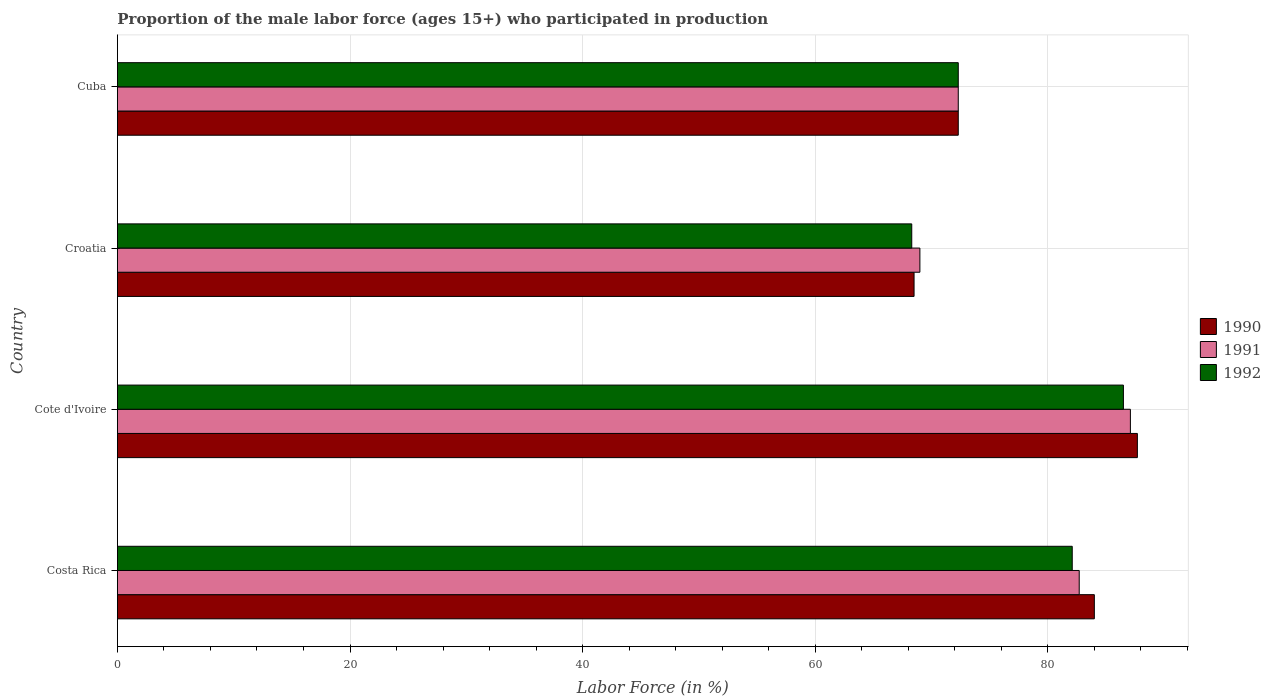How many groups of bars are there?
Provide a short and direct response. 4. Are the number of bars per tick equal to the number of legend labels?
Provide a succinct answer. Yes. Are the number of bars on each tick of the Y-axis equal?
Your answer should be very brief. Yes. How many bars are there on the 4th tick from the top?
Offer a terse response. 3. What is the label of the 2nd group of bars from the top?
Offer a very short reply. Croatia. What is the proportion of the male labor force who participated in production in 1991 in Croatia?
Provide a short and direct response. 69. Across all countries, what is the maximum proportion of the male labor force who participated in production in 1990?
Give a very brief answer. 87.7. Across all countries, what is the minimum proportion of the male labor force who participated in production in 1990?
Keep it short and to the point. 68.5. In which country was the proportion of the male labor force who participated in production in 1992 maximum?
Ensure brevity in your answer.  Cote d'Ivoire. In which country was the proportion of the male labor force who participated in production in 1990 minimum?
Make the answer very short. Croatia. What is the total proportion of the male labor force who participated in production in 1991 in the graph?
Your answer should be very brief. 311.1. What is the difference between the proportion of the male labor force who participated in production in 1992 in Costa Rica and that in Cote d'Ivoire?
Offer a terse response. -4.4. What is the difference between the proportion of the male labor force who participated in production in 1991 in Croatia and the proportion of the male labor force who participated in production in 1992 in Cote d'Ivoire?
Provide a short and direct response. -17.5. What is the average proportion of the male labor force who participated in production in 1992 per country?
Keep it short and to the point. 77.3. What is the difference between the proportion of the male labor force who participated in production in 1992 and proportion of the male labor force who participated in production in 1991 in Costa Rica?
Your response must be concise. -0.6. What is the ratio of the proportion of the male labor force who participated in production in 1990 in Costa Rica to that in Cuba?
Give a very brief answer. 1.16. What is the difference between the highest and the second highest proportion of the male labor force who participated in production in 1990?
Offer a very short reply. 3.7. What is the difference between the highest and the lowest proportion of the male labor force who participated in production in 1992?
Make the answer very short. 18.2. Is the sum of the proportion of the male labor force who participated in production in 1991 in Cote d'Ivoire and Cuba greater than the maximum proportion of the male labor force who participated in production in 1992 across all countries?
Offer a very short reply. Yes. What does the 1st bar from the top in Croatia represents?
Provide a succinct answer. 1992. How many bars are there?
Provide a short and direct response. 12. Does the graph contain any zero values?
Offer a terse response. No. Does the graph contain grids?
Offer a terse response. Yes. How many legend labels are there?
Offer a terse response. 3. What is the title of the graph?
Your response must be concise. Proportion of the male labor force (ages 15+) who participated in production. What is the label or title of the X-axis?
Offer a terse response. Labor Force (in %). What is the Labor Force (in %) in 1990 in Costa Rica?
Ensure brevity in your answer.  84. What is the Labor Force (in %) in 1991 in Costa Rica?
Provide a short and direct response. 82.7. What is the Labor Force (in %) of 1992 in Costa Rica?
Make the answer very short. 82.1. What is the Labor Force (in %) of 1990 in Cote d'Ivoire?
Your answer should be very brief. 87.7. What is the Labor Force (in %) of 1991 in Cote d'Ivoire?
Your answer should be very brief. 87.1. What is the Labor Force (in %) of 1992 in Cote d'Ivoire?
Provide a short and direct response. 86.5. What is the Labor Force (in %) of 1990 in Croatia?
Ensure brevity in your answer.  68.5. What is the Labor Force (in %) in 1992 in Croatia?
Your answer should be compact. 68.3. What is the Labor Force (in %) in 1990 in Cuba?
Offer a terse response. 72.3. What is the Labor Force (in %) of 1991 in Cuba?
Offer a terse response. 72.3. What is the Labor Force (in %) of 1992 in Cuba?
Your answer should be very brief. 72.3. Across all countries, what is the maximum Labor Force (in %) in 1990?
Ensure brevity in your answer.  87.7. Across all countries, what is the maximum Labor Force (in %) of 1991?
Keep it short and to the point. 87.1. Across all countries, what is the maximum Labor Force (in %) of 1992?
Give a very brief answer. 86.5. Across all countries, what is the minimum Labor Force (in %) of 1990?
Keep it short and to the point. 68.5. Across all countries, what is the minimum Labor Force (in %) in 1992?
Your response must be concise. 68.3. What is the total Labor Force (in %) in 1990 in the graph?
Your answer should be very brief. 312.5. What is the total Labor Force (in %) in 1991 in the graph?
Offer a very short reply. 311.1. What is the total Labor Force (in %) in 1992 in the graph?
Your answer should be very brief. 309.2. What is the difference between the Labor Force (in %) of 1990 in Costa Rica and that in Cote d'Ivoire?
Your answer should be very brief. -3.7. What is the difference between the Labor Force (in %) in 1990 in Costa Rica and that in Croatia?
Your response must be concise. 15.5. What is the difference between the Labor Force (in %) in 1991 in Costa Rica and that in Croatia?
Offer a very short reply. 13.7. What is the difference between the Labor Force (in %) of 1991 in Costa Rica and that in Cuba?
Ensure brevity in your answer.  10.4. What is the difference between the Labor Force (in %) of 1990 in Cote d'Ivoire and that in Croatia?
Your answer should be very brief. 19.2. What is the difference between the Labor Force (in %) in 1991 in Cote d'Ivoire and that in Croatia?
Give a very brief answer. 18.1. What is the difference between the Labor Force (in %) in 1990 in Cote d'Ivoire and that in Cuba?
Ensure brevity in your answer.  15.4. What is the difference between the Labor Force (in %) of 1991 in Cote d'Ivoire and that in Cuba?
Your answer should be very brief. 14.8. What is the difference between the Labor Force (in %) in 1992 in Cote d'Ivoire and that in Cuba?
Give a very brief answer. 14.2. What is the difference between the Labor Force (in %) of 1990 in Costa Rica and the Labor Force (in %) of 1992 in Cote d'Ivoire?
Provide a short and direct response. -2.5. What is the difference between the Labor Force (in %) in 1991 in Costa Rica and the Labor Force (in %) in 1992 in Cote d'Ivoire?
Provide a short and direct response. -3.8. What is the difference between the Labor Force (in %) in 1990 in Costa Rica and the Labor Force (in %) in 1992 in Croatia?
Offer a terse response. 15.7. What is the difference between the Labor Force (in %) in 1991 in Costa Rica and the Labor Force (in %) in 1992 in Croatia?
Offer a very short reply. 14.4. What is the difference between the Labor Force (in %) in 1990 in Costa Rica and the Labor Force (in %) in 1991 in Cuba?
Ensure brevity in your answer.  11.7. What is the difference between the Labor Force (in %) in 1990 in Costa Rica and the Labor Force (in %) in 1992 in Cuba?
Your answer should be very brief. 11.7. What is the difference between the Labor Force (in %) in 1990 in Cote d'Ivoire and the Labor Force (in %) in 1991 in Croatia?
Your answer should be very brief. 18.7. What is the difference between the Labor Force (in %) of 1990 in Cote d'Ivoire and the Labor Force (in %) of 1991 in Cuba?
Offer a terse response. 15.4. What is the difference between the Labor Force (in %) of 1990 in Cote d'Ivoire and the Labor Force (in %) of 1992 in Cuba?
Offer a terse response. 15.4. What is the difference between the Labor Force (in %) of 1991 in Cote d'Ivoire and the Labor Force (in %) of 1992 in Cuba?
Your answer should be very brief. 14.8. What is the difference between the Labor Force (in %) of 1990 in Croatia and the Labor Force (in %) of 1992 in Cuba?
Provide a succinct answer. -3.8. What is the difference between the Labor Force (in %) of 1991 in Croatia and the Labor Force (in %) of 1992 in Cuba?
Keep it short and to the point. -3.3. What is the average Labor Force (in %) of 1990 per country?
Offer a very short reply. 78.12. What is the average Labor Force (in %) in 1991 per country?
Give a very brief answer. 77.78. What is the average Labor Force (in %) in 1992 per country?
Your answer should be compact. 77.3. What is the difference between the Labor Force (in %) in 1990 and Labor Force (in %) in 1991 in Costa Rica?
Offer a terse response. 1.3. What is the difference between the Labor Force (in %) in 1990 and Labor Force (in %) in 1991 in Croatia?
Give a very brief answer. -0.5. What is the difference between the Labor Force (in %) of 1990 and Labor Force (in %) of 1992 in Croatia?
Provide a short and direct response. 0.2. What is the difference between the Labor Force (in %) in 1990 and Labor Force (in %) in 1991 in Cuba?
Provide a short and direct response. 0. What is the difference between the Labor Force (in %) of 1990 and Labor Force (in %) of 1992 in Cuba?
Your response must be concise. 0. What is the ratio of the Labor Force (in %) in 1990 in Costa Rica to that in Cote d'Ivoire?
Your answer should be compact. 0.96. What is the ratio of the Labor Force (in %) in 1991 in Costa Rica to that in Cote d'Ivoire?
Provide a short and direct response. 0.95. What is the ratio of the Labor Force (in %) in 1992 in Costa Rica to that in Cote d'Ivoire?
Make the answer very short. 0.95. What is the ratio of the Labor Force (in %) of 1990 in Costa Rica to that in Croatia?
Your answer should be compact. 1.23. What is the ratio of the Labor Force (in %) of 1991 in Costa Rica to that in Croatia?
Offer a terse response. 1.2. What is the ratio of the Labor Force (in %) of 1992 in Costa Rica to that in Croatia?
Ensure brevity in your answer.  1.2. What is the ratio of the Labor Force (in %) of 1990 in Costa Rica to that in Cuba?
Keep it short and to the point. 1.16. What is the ratio of the Labor Force (in %) of 1991 in Costa Rica to that in Cuba?
Offer a very short reply. 1.14. What is the ratio of the Labor Force (in %) of 1992 in Costa Rica to that in Cuba?
Give a very brief answer. 1.14. What is the ratio of the Labor Force (in %) of 1990 in Cote d'Ivoire to that in Croatia?
Your answer should be compact. 1.28. What is the ratio of the Labor Force (in %) of 1991 in Cote d'Ivoire to that in Croatia?
Your answer should be compact. 1.26. What is the ratio of the Labor Force (in %) in 1992 in Cote d'Ivoire to that in Croatia?
Offer a terse response. 1.27. What is the ratio of the Labor Force (in %) in 1990 in Cote d'Ivoire to that in Cuba?
Offer a terse response. 1.21. What is the ratio of the Labor Force (in %) in 1991 in Cote d'Ivoire to that in Cuba?
Ensure brevity in your answer.  1.2. What is the ratio of the Labor Force (in %) in 1992 in Cote d'Ivoire to that in Cuba?
Offer a terse response. 1.2. What is the ratio of the Labor Force (in %) of 1990 in Croatia to that in Cuba?
Keep it short and to the point. 0.95. What is the ratio of the Labor Force (in %) of 1991 in Croatia to that in Cuba?
Make the answer very short. 0.95. What is the ratio of the Labor Force (in %) of 1992 in Croatia to that in Cuba?
Make the answer very short. 0.94. What is the difference between the highest and the second highest Labor Force (in %) in 1990?
Keep it short and to the point. 3.7. What is the difference between the highest and the lowest Labor Force (in %) in 1990?
Offer a terse response. 19.2. What is the difference between the highest and the lowest Labor Force (in %) of 1991?
Ensure brevity in your answer.  18.1. 